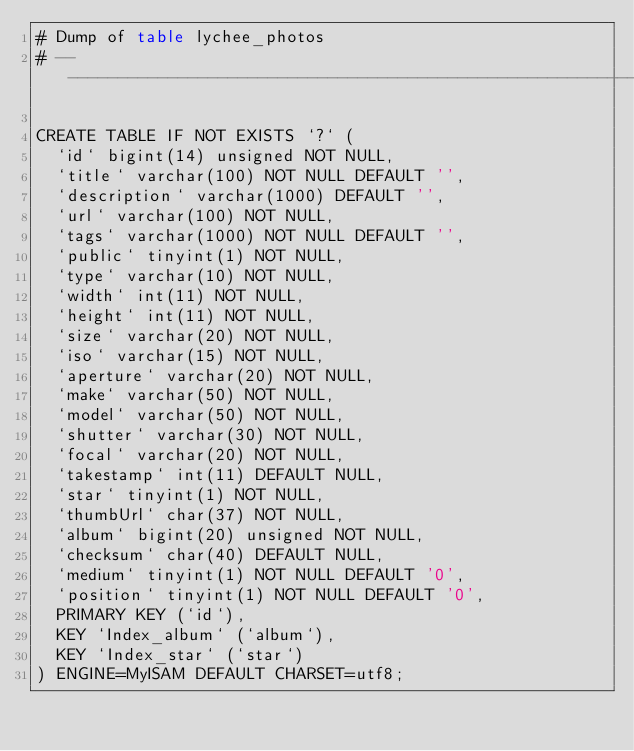<code> <loc_0><loc_0><loc_500><loc_500><_SQL_># Dump of table lychee_photos
# ------------------------------------------------------------

CREATE TABLE IF NOT EXISTS `?` (
  `id` bigint(14) unsigned NOT NULL,
  `title` varchar(100) NOT NULL DEFAULT '',
  `description` varchar(1000) DEFAULT '',
  `url` varchar(100) NOT NULL,
  `tags` varchar(1000) NOT NULL DEFAULT '',
  `public` tinyint(1) NOT NULL,
  `type` varchar(10) NOT NULL,
  `width` int(11) NOT NULL,
  `height` int(11) NOT NULL,
  `size` varchar(20) NOT NULL,
  `iso` varchar(15) NOT NULL,
  `aperture` varchar(20) NOT NULL,
  `make` varchar(50) NOT NULL,
  `model` varchar(50) NOT NULL,
  `shutter` varchar(30) NOT NULL,
  `focal` varchar(20) NOT NULL,
  `takestamp` int(11) DEFAULT NULL,
  `star` tinyint(1) NOT NULL,
  `thumbUrl` char(37) NOT NULL,
  `album` bigint(20) unsigned NOT NULL,
  `checksum` char(40) DEFAULT NULL,
  `medium` tinyint(1) NOT NULL DEFAULT '0',
  `position` tinyint(1) NOT NULL DEFAULT '0',
  PRIMARY KEY (`id`),
  KEY `Index_album` (`album`),
  KEY `Index_star` (`star`)
) ENGINE=MyISAM DEFAULT CHARSET=utf8;
</code> 